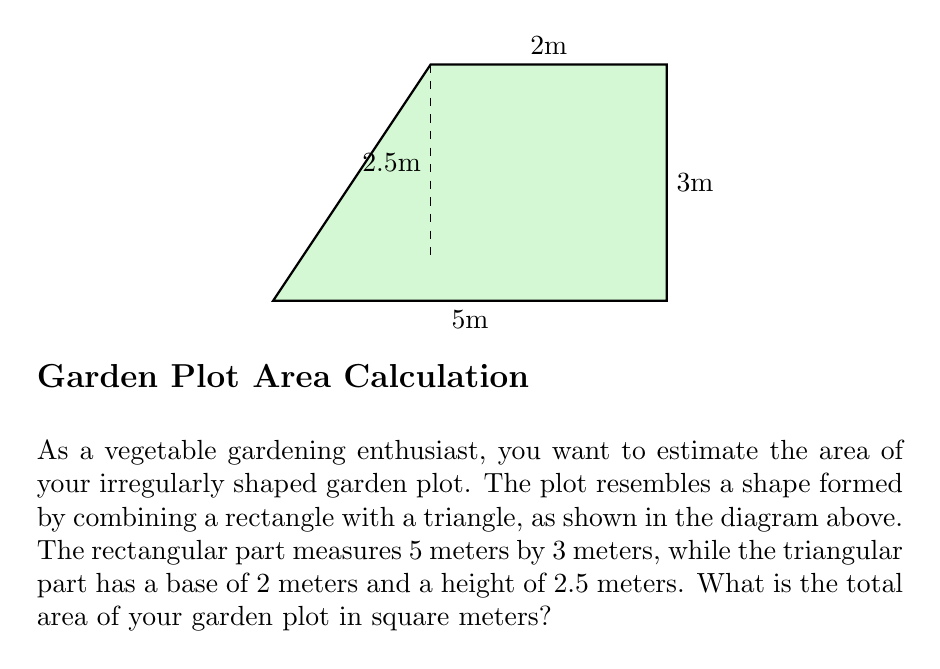Could you help me with this problem? To calculate the total area of the irregularly shaped garden plot, we need to break it down into two parts: a rectangle and a triangle. Let's solve this step-by-step:

1. Calculate the area of the rectangular part:
   $$ A_{rectangle} = length \times width $$
   $$ A_{rectangle} = 5\text{ m} \times 3\text{ m} = 15\text{ m}^2 $$

2. Calculate the area of the triangular part:
   $$ A_{triangle} = \frac{1}{2} \times base \times height $$
   $$ A_{triangle} = \frac{1}{2} \times 2\text{ m} \times 2.5\text{ m} = 2.5\text{ m}^2 $$

3. Sum up the areas to get the total area:
   $$ A_{total} = A_{rectangle} + A_{triangle} $$
   $$ A_{total} = 15\text{ m}^2 + 2.5\text{ m}^2 = 17.5\text{ m}^2 $$

Therefore, the total area of your garden plot is 17.5 square meters.
Answer: 17.5 m² 